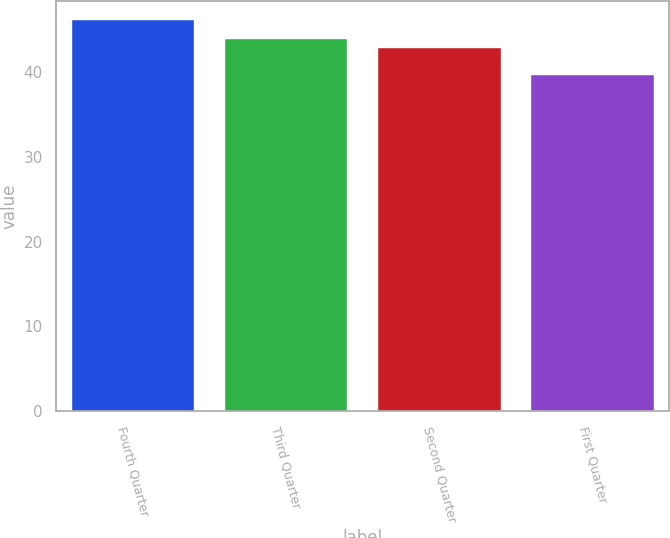Convert chart. <chart><loc_0><loc_0><loc_500><loc_500><bar_chart><fcel>Fourth Quarter<fcel>Third Quarter<fcel>Second Quarter<fcel>First Quarter<nl><fcel>46.07<fcel>43.86<fcel>42.82<fcel>39.59<nl></chart> 